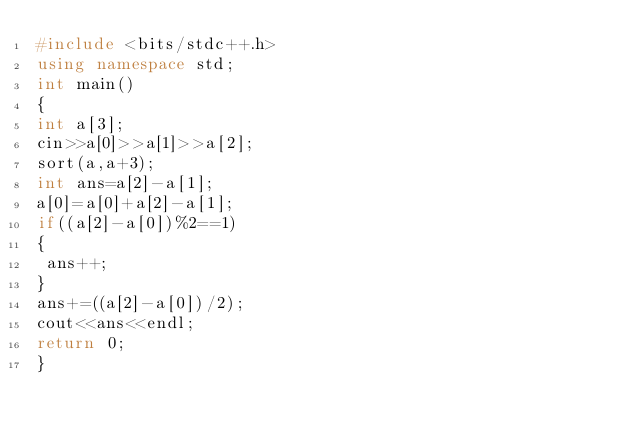Convert code to text. <code><loc_0><loc_0><loc_500><loc_500><_C++_>#include <bits/stdc++.h>
using namespace std;
int main()
{
int a[3];
cin>>a[0]>>a[1]>>a[2];
sort(a,a+3);
int ans=a[2]-a[1];
a[0]=a[0]+a[2]-a[1];
if((a[2]-a[0])%2==1)
{
 ans++;
}
ans+=((a[2]-a[0])/2);
cout<<ans<<endl;
return 0;
}</code> 